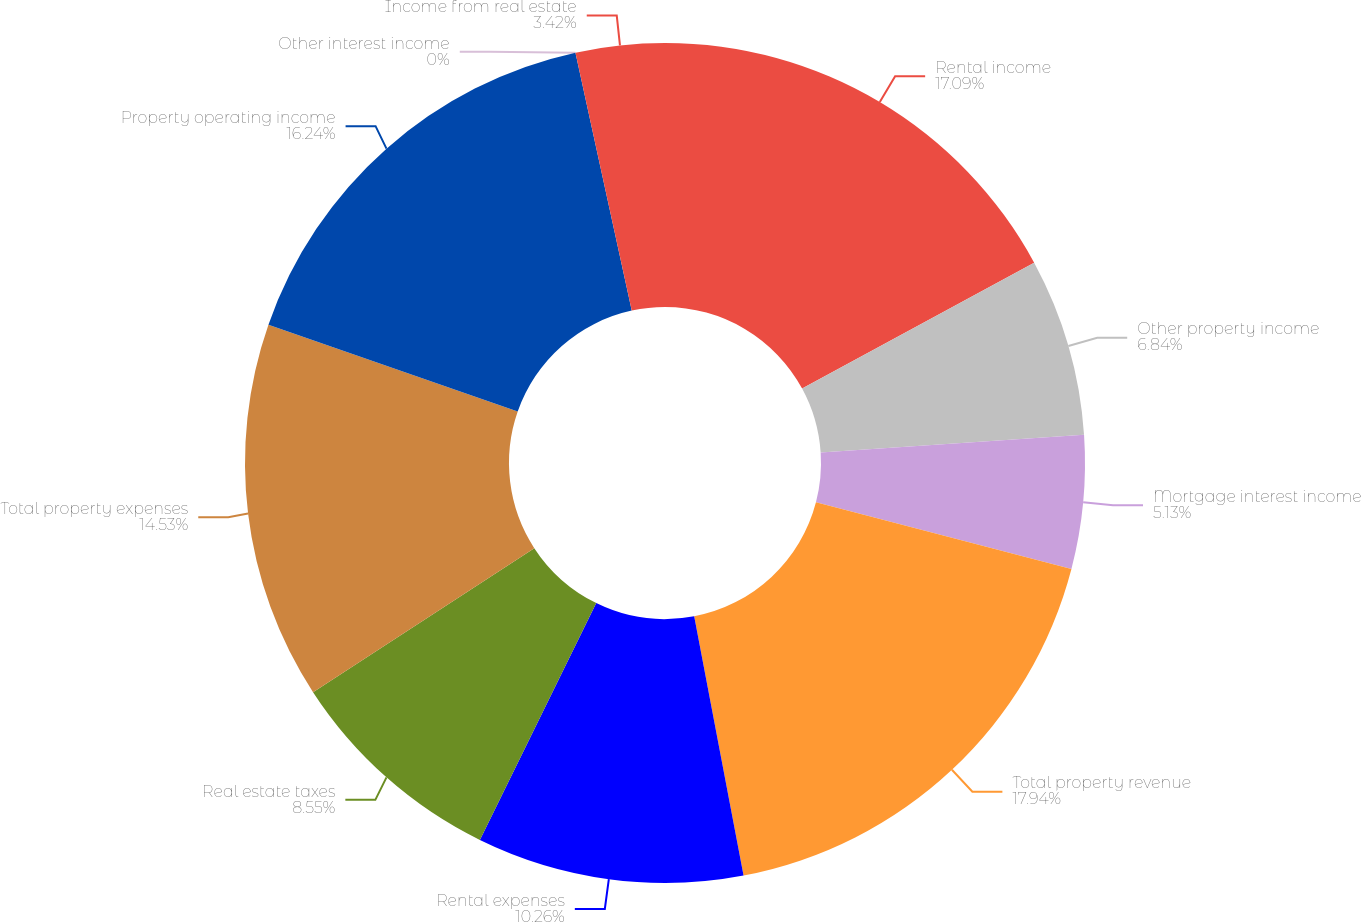Convert chart. <chart><loc_0><loc_0><loc_500><loc_500><pie_chart><fcel>Rental income<fcel>Other property income<fcel>Mortgage interest income<fcel>Total property revenue<fcel>Rental expenses<fcel>Real estate taxes<fcel>Total property expenses<fcel>Property operating income<fcel>Other interest income<fcel>Income from real estate<nl><fcel>17.09%<fcel>6.84%<fcel>5.13%<fcel>17.95%<fcel>10.26%<fcel>8.55%<fcel>14.53%<fcel>16.24%<fcel>0.0%<fcel>3.42%<nl></chart> 